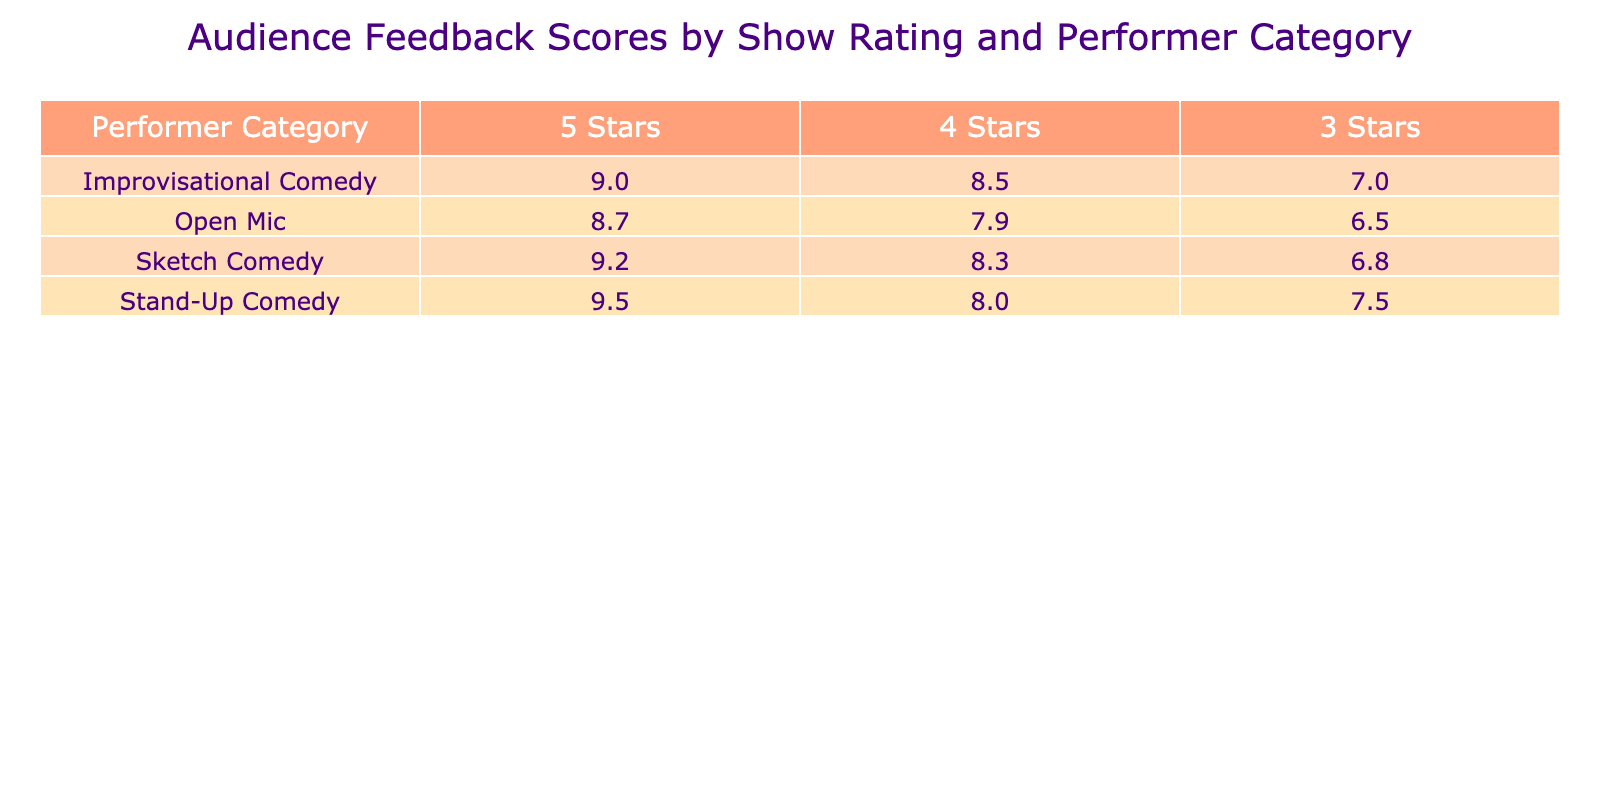What is the highest audience feedback score for Stand-Up Comedy? The highest score for Stand-Up Comedy is noted in the 5 Stars column, which shows a score of 9.5.
Answer: 9.5 What audience feedback score did Improvisational Comedy receive for a 3 Stars rating? For Improvisational Comedy in the 3 Stars column, the score listed is 7.0.
Answer: 7.0 Which performer category has the lowest score among the 5 Stars ratings? By checking the 5 Stars ratings column, Stand-Up Comedy has the highest score at 9.5, and Open Mic has the lowest at 8.7, therefore Open Mic has the lowest score among the 5 Stars ratings.
Answer: Open Mic What is the average audience feedback score for Sketch Comedy? The scores for Sketch Comedy are 9.2, 8.3, and 6.8. Adding these scores gives 9.2 + 8.3 + 6.8 = 24.3, and since there are 3 scores, the average is 24.3 / 3 = 8.1.
Answer: 8.1 Is the audience feedback score for Open Mic higher than that for Improvisational Comedy in the 4 Stars category? The Open Mic score in the 4 Stars category is 7.9, and the Improvisational Comedy score in that category is 8.5. Since 7.9 is less than 8.5, the statement is false.
Answer: No Which performer category has the highest audience feedback score for a 4 Stars rating? Looking at the 4 Stars column, the scores are 8.0 for Stand-Up Comedy, 8.5 for Improvisational Comedy, and 8.3 for Sketch Comedy. Comparatively, the highest score is 8.5 from Improvisational Comedy.
Answer: Improvisational Comedy What is the difference between the highest and lowest feedback score among the 3 Stars ratings? The highest 3 Stars rating is 7.5 for Stand-Up Comedy and the lowest is 6.5 for Open Mic. The difference is 7.5 - 6.5 = 1.0.
Answer: 1.0 Did any performer category receive a score of 10 or higher? Upon examining all feedback scores listed in the table, the highest score is 9.5 for Stand-Up Comedy, which is below 10. Therefore, the answer is no.
Answer: No 